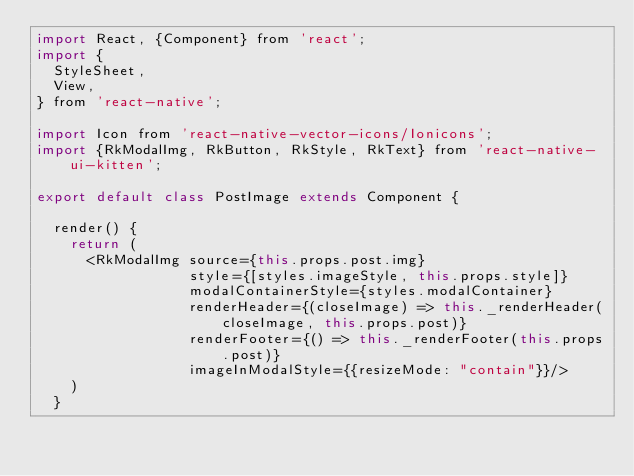Convert code to text. <code><loc_0><loc_0><loc_500><loc_500><_JavaScript_>import React, {Component} from 'react';
import {
  StyleSheet,
  View,
} from 'react-native';

import Icon from 'react-native-vector-icons/Ionicons';
import {RkModalImg, RkButton, RkStyle, RkText} from 'react-native-ui-kitten';

export default class PostImage extends Component {

  render() {
    return (
      <RkModalImg source={this.props.post.img}
                  style={[styles.imageStyle, this.props.style]}
                  modalContainerStyle={styles.modalContainer}
                  renderHeader={(closeImage) => this._renderHeader(closeImage, this.props.post)}
                  renderFooter={() => this._renderFooter(this.props.post)}
                  imageInModalStyle={{resizeMode: "contain"}}/>
    )
  }
</code> 